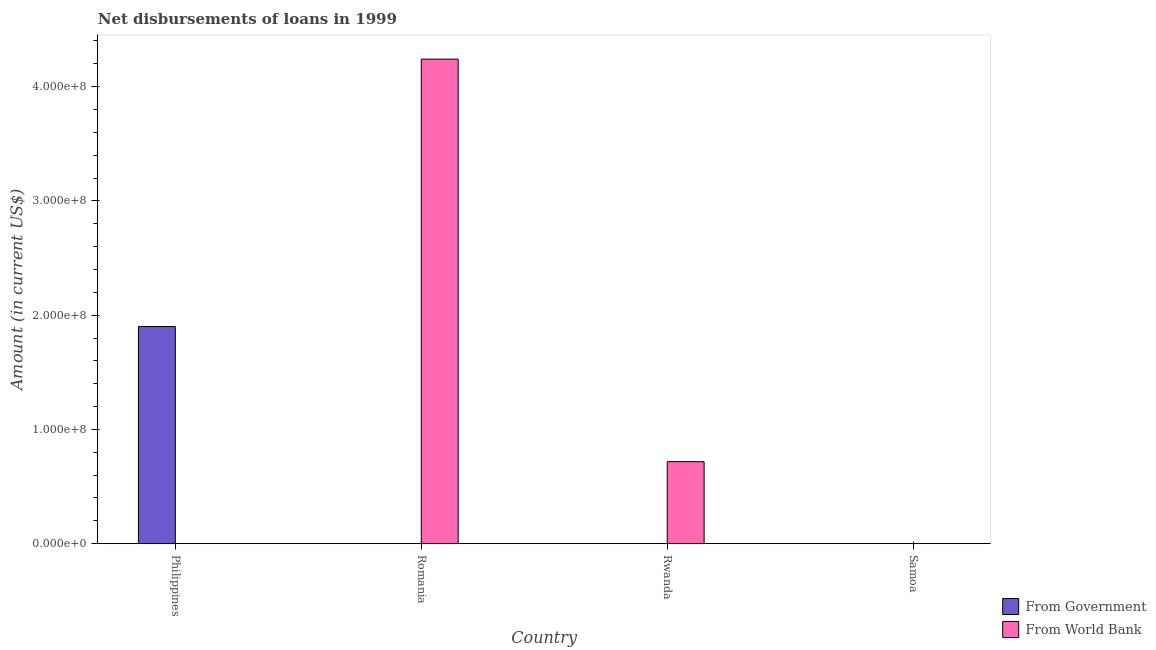Are the number of bars per tick equal to the number of legend labels?
Provide a short and direct response. No. How many bars are there on the 4th tick from the right?
Your answer should be very brief. 1. What is the label of the 2nd group of bars from the left?
Offer a very short reply. Romania. In how many cases, is the number of bars for a given country not equal to the number of legend labels?
Keep it short and to the point. 4. What is the net disbursements of loan from government in Samoa?
Your response must be concise. 0. Across all countries, what is the maximum net disbursements of loan from world bank?
Offer a terse response. 4.24e+08. Across all countries, what is the minimum net disbursements of loan from government?
Provide a succinct answer. 0. In which country was the net disbursements of loan from government maximum?
Your answer should be very brief. Philippines. What is the total net disbursements of loan from world bank in the graph?
Provide a succinct answer. 4.96e+08. What is the difference between the net disbursements of loan from government in Philippines and the net disbursements of loan from world bank in Romania?
Keep it short and to the point. -2.34e+08. What is the average net disbursements of loan from government per country?
Provide a succinct answer. 4.75e+07. In how many countries, is the net disbursements of loan from government greater than 240000000 US$?
Provide a short and direct response. 0. What is the difference between the highest and the lowest net disbursements of loan from world bank?
Offer a very short reply. 4.24e+08. Is the sum of the net disbursements of loan from world bank in Romania and Rwanda greater than the maximum net disbursements of loan from government across all countries?
Your response must be concise. Yes. How many bars are there?
Your answer should be compact. 3. Are all the bars in the graph horizontal?
Ensure brevity in your answer.  No. How many countries are there in the graph?
Keep it short and to the point. 4. What is the difference between two consecutive major ticks on the Y-axis?
Provide a short and direct response. 1.00e+08. Does the graph contain grids?
Ensure brevity in your answer.  No. Where does the legend appear in the graph?
Keep it short and to the point. Bottom right. How are the legend labels stacked?
Your response must be concise. Vertical. What is the title of the graph?
Give a very brief answer. Net disbursements of loans in 1999. What is the label or title of the X-axis?
Ensure brevity in your answer.  Country. What is the Amount (in current US$) of From Government in Philippines?
Make the answer very short. 1.90e+08. What is the Amount (in current US$) of From World Bank in Romania?
Ensure brevity in your answer.  4.24e+08. What is the Amount (in current US$) in From World Bank in Rwanda?
Your response must be concise. 7.18e+07. What is the Amount (in current US$) of From Government in Samoa?
Your response must be concise. 0. Across all countries, what is the maximum Amount (in current US$) of From Government?
Provide a succinct answer. 1.90e+08. Across all countries, what is the maximum Amount (in current US$) in From World Bank?
Ensure brevity in your answer.  4.24e+08. Across all countries, what is the minimum Amount (in current US$) of From Government?
Your answer should be compact. 0. Across all countries, what is the minimum Amount (in current US$) in From World Bank?
Your response must be concise. 0. What is the total Amount (in current US$) in From Government in the graph?
Provide a short and direct response. 1.90e+08. What is the total Amount (in current US$) of From World Bank in the graph?
Your answer should be compact. 4.96e+08. What is the difference between the Amount (in current US$) in From World Bank in Romania and that in Rwanda?
Your answer should be compact. 3.52e+08. What is the difference between the Amount (in current US$) in From Government in Philippines and the Amount (in current US$) in From World Bank in Romania?
Keep it short and to the point. -2.34e+08. What is the difference between the Amount (in current US$) of From Government in Philippines and the Amount (in current US$) of From World Bank in Rwanda?
Your answer should be very brief. 1.18e+08. What is the average Amount (in current US$) in From Government per country?
Ensure brevity in your answer.  4.75e+07. What is the average Amount (in current US$) in From World Bank per country?
Provide a succinct answer. 1.24e+08. What is the ratio of the Amount (in current US$) of From World Bank in Romania to that in Rwanda?
Your response must be concise. 5.91. What is the difference between the highest and the lowest Amount (in current US$) in From Government?
Provide a succinct answer. 1.90e+08. What is the difference between the highest and the lowest Amount (in current US$) of From World Bank?
Your answer should be very brief. 4.24e+08. 